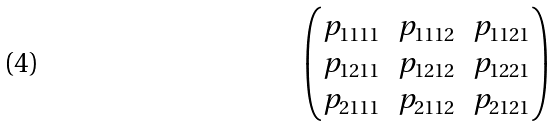<formula> <loc_0><loc_0><loc_500><loc_500>\begin{pmatrix} p _ { 1 1 1 1 } & p _ { 1 1 1 2 } & p _ { 1 1 2 1 } \\ p _ { 1 2 1 1 } & p _ { 1 2 1 2 } & p _ { 1 2 2 1 } \\ p _ { 2 1 1 1 } & p _ { 2 1 1 2 } & p _ { 2 1 2 1 } \\ \end{pmatrix}</formula> 